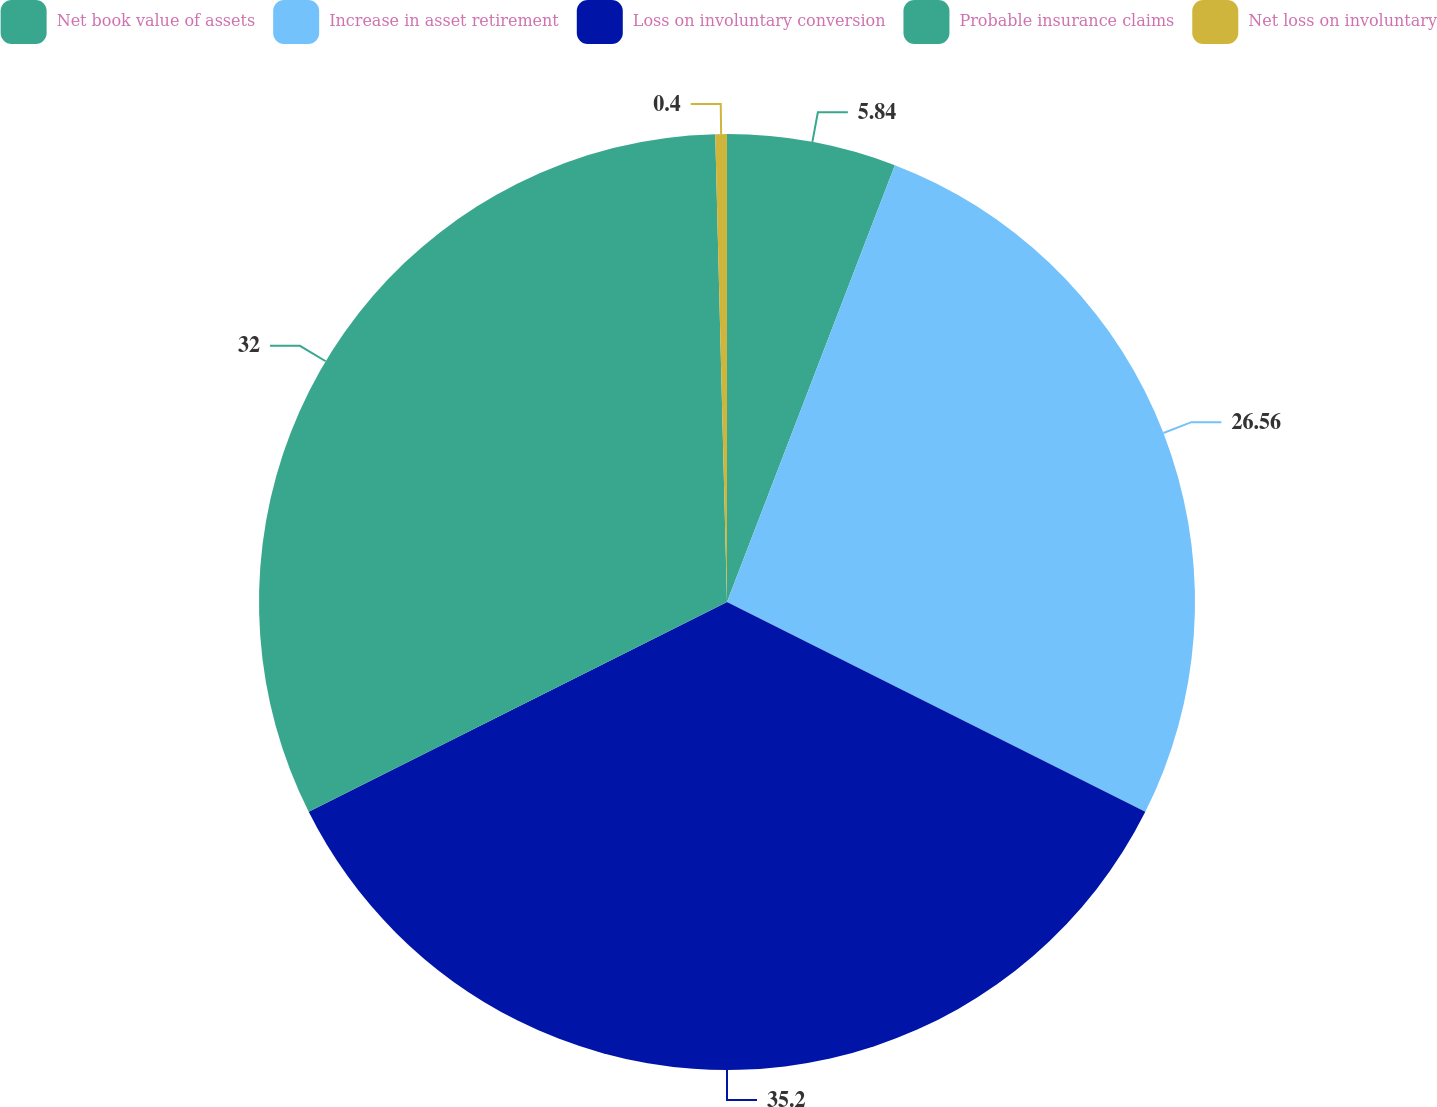Convert chart to OTSL. <chart><loc_0><loc_0><loc_500><loc_500><pie_chart><fcel>Net book value of assets<fcel>Increase in asset retirement<fcel>Loss on involuntary conversion<fcel>Probable insurance claims<fcel>Net loss on involuntary<nl><fcel>5.84%<fcel>26.56%<fcel>35.2%<fcel>32.0%<fcel>0.4%<nl></chart> 